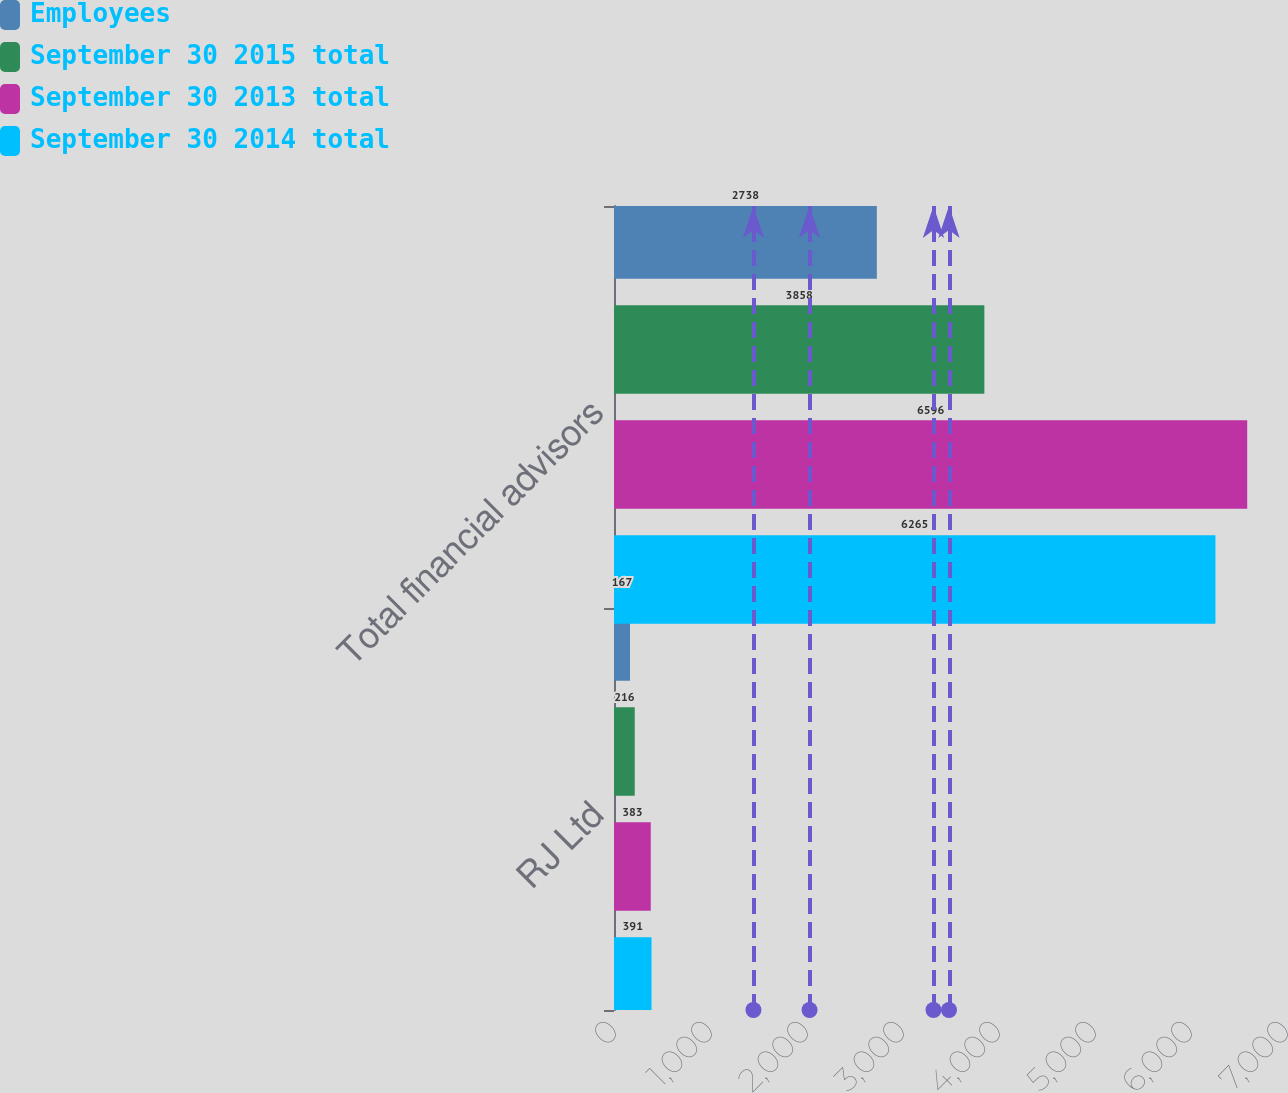Convert chart. <chart><loc_0><loc_0><loc_500><loc_500><stacked_bar_chart><ecel><fcel>RJ Ltd<fcel>Total financial advisors<nl><fcel>Employees<fcel>167<fcel>2738<nl><fcel>September 30 2015 total<fcel>216<fcel>3858<nl><fcel>September 30 2013 total<fcel>383<fcel>6596<nl><fcel>September 30 2014 total<fcel>391<fcel>6265<nl></chart> 